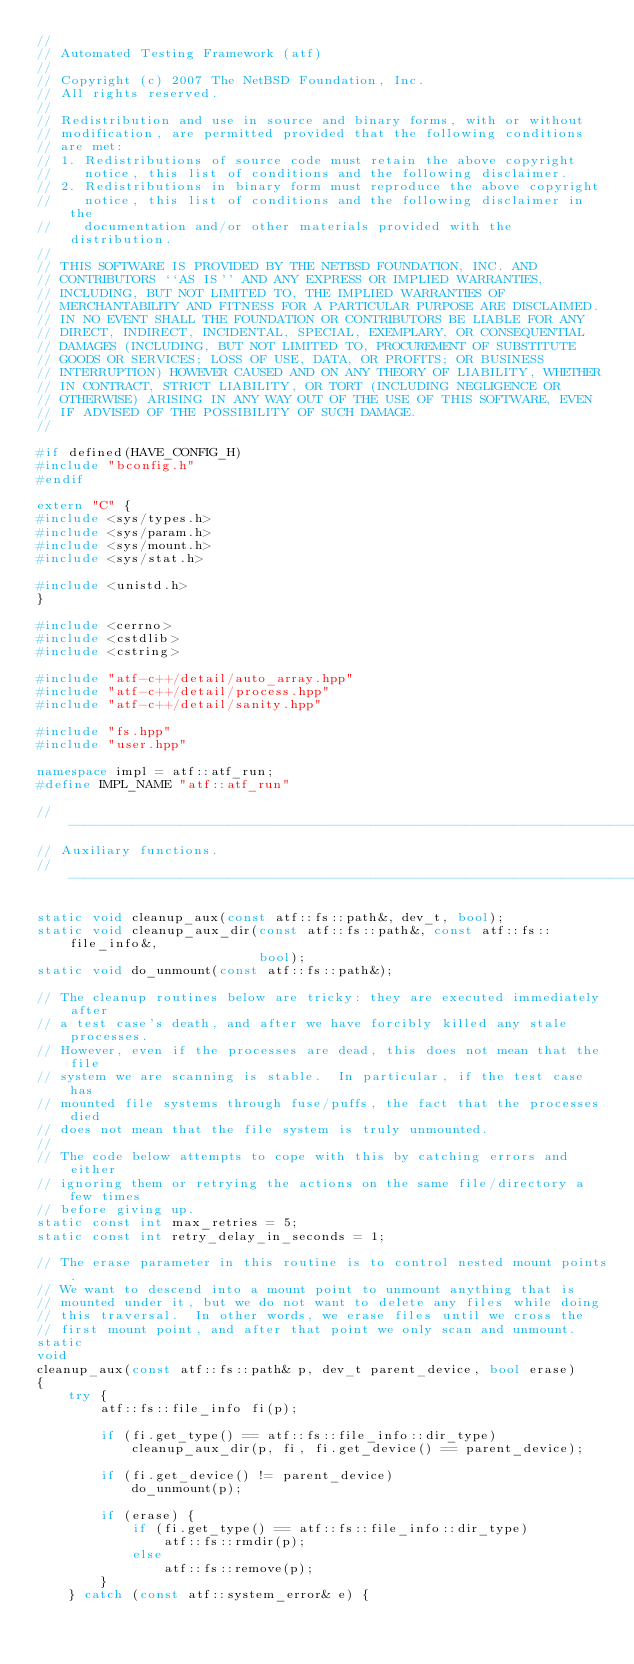<code> <loc_0><loc_0><loc_500><loc_500><_C++_>//
// Automated Testing Framework (atf)
//
// Copyright (c) 2007 The NetBSD Foundation, Inc.
// All rights reserved.
//
// Redistribution and use in source and binary forms, with or without
// modification, are permitted provided that the following conditions
// are met:
// 1. Redistributions of source code must retain the above copyright
//    notice, this list of conditions and the following disclaimer.
// 2. Redistributions in binary form must reproduce the above copyright
//    notice, this list of conditions and the following disclaimer in the
//    documentation and/or other materials provided with the distribution.
//
// THIS SOFTWARE IS PROVIDED BY THE NETBSD FOUNDATION, INC. AND
// CONTRIBUTORS ``AS IS'' AND ANY EXPRESS OR IMPLIED WARRANTIES,
// INCLUDING, BUT NOT LIMITED TO, THE IMPLIED WARRANTIES OF
// MERCHANTABILITY AND FITNESS FOR A PARTICULAR PURPOSE ARE DISCLAIMED.
// IN NO EVENT SHALL THE FOUNDATION OR CONTRIBUTORS BE LIABLE FOR ANY
// DIRECT, INDIRECT, INCIDENTAL, SPECIAL, EXEMPLARY, OR CONSEQUENTIAL
// DAMAGES (INCLUDING, BUT NOT LIMITED TO, PROCUREMENT OF SUBSTITUTE
// GOODS OR SERVICES; LOSS OF USE, DATA, OR PROFITS; OR BUSINESS
// INTERRUPTION) HOWEVER CAUSED AND ON ANY THEORY OF LIABILITY, WHETHER
// IN CONTRACT, STRICT LIABILITY, OR TORT (INCLUDING NEGLIGENCE OR
// OTHERWISE) ARISING IN ANY WAY OUT OF THE USE OF THIS SOFTWARE, EVEN
// IF ADVISED OF THE POSSIBILITY OF SUCH DAMAGE.
//

#if defined(HAVE_CONFIG_H)
#include "bconfig.h"
#endif

extern "C" {
#include <sys/types.h>
#include <sys/param.h>
#include <sys/mount.h>
#include <sys/stat.h>

#include <unistd.h>
}

#include <cerrno>
#include <cstdlib>
#include <cstring>

#include "atf-c++/detail/auto_array.hpp"
#include "atf-c++/detail/process.hpp"
#include "atf-c++/detail/sanity.hpp"

#include "fs.hpp"
#include "user.hpp"

namespace impl = atf::atf_run;
#define IMPL_NAME "atf::atf_run"

// ------------------------------------------------------------------------
// Auxiliary functions.
// ------------------------------------------------------------------------

static void cleanup_aux(const atf::fs::path&, dev_t, bool);
static void cleanup_aux_dir(const atf::fs::path&, const atf::fs::file_info&,
                            bool);
static void do_unmount(const atf::fs::path&);

// The cleanup routines below are tricky: they are executed immediately after
// a test case's death, and after we have forcibly killed any stale processes.
// However, even if the processes are dead, this does not mean that the file
// system we are scanning is stable.  In particular, if the test case has
// mounted file systems through fuse/puffs, the fact that the processes died
// does not mean that the file system is truly unmounted.
//
// The code below attempts to cope with this by catching errors and either
// ignoring them or retrying the actions on the same file/directory a few times
// before giving up.
static const int max_retries = 5;
static const int retry_delay_in_seconds = 1;

// The erase parameter in this routine is to control nested mount points.
// We want to descend into a mount point to unmount anything that is
// mounted under it, but we do not want to delete any files while doing
// this traversal.  In other words, we erase files until we cross the
// first mount point, and after that point we only scan and unmount.
static
void
cleanup_aux(const atf::fs::path& p, dev_t parent_device, bool erase)
{
    try {
        atf::fs::file_info fi(p);

        if (fi.get_type() == atf::fs::file_info::dir_type)
            cleanup_aux_dir(p, fi, fi.get_device() == parent_device);

        if (fi.get_device() != parent_device)
            do_unmount(p);

        if (erase) {
            if (fi.get_type() == atf::fs::file_info::dir_type)
                atf::fs::rmdir(p);
            else
                atf::fs::remove(p);
        }
    } catch (const atf::system_error& e) {</code> 